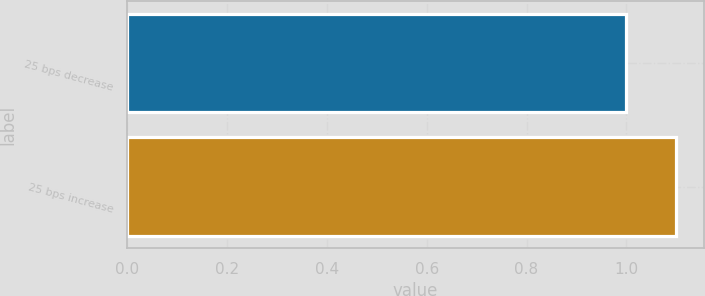Convert chart. <chart><loc_0><loc_0><loc_500><loc_500><bar_chart><fcel>25 bps decrease<fcel>25 bps increase<nl><fcel>1<fcel>1.1<nl></chart> 